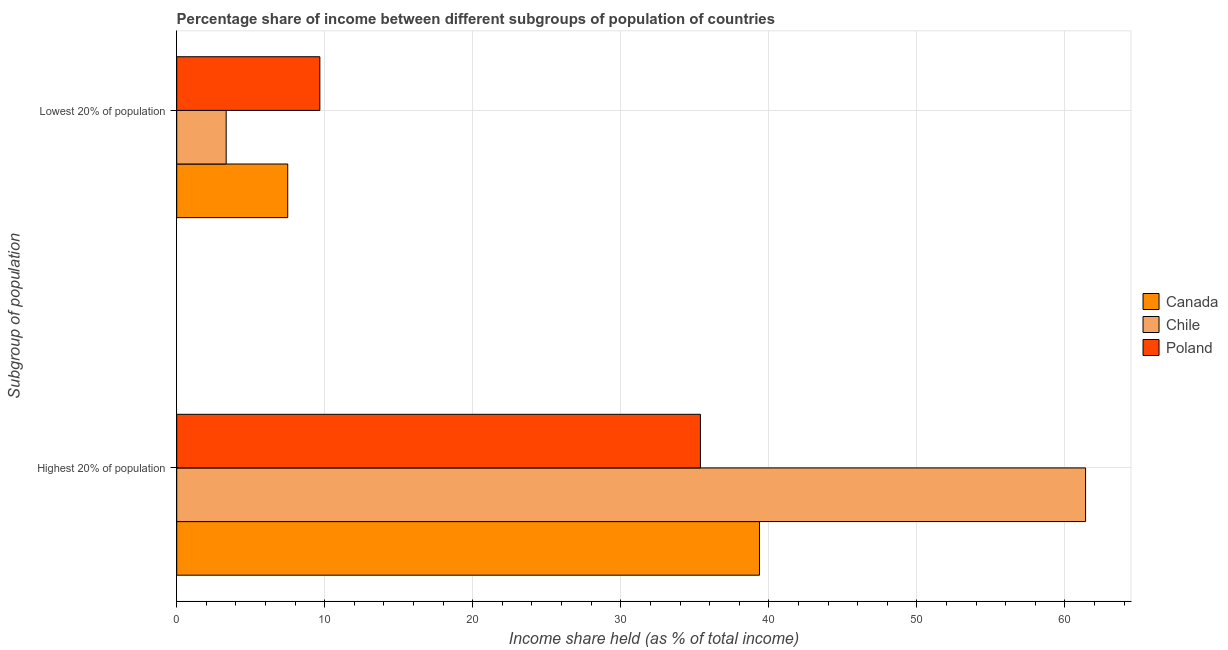How many different coloured bars are there?
Ensure brevity in your answer.  3. How many groups of bars are there?
Provide a short and direct response. 2. Are the number of bars on each tick of the Y-axis equal?
Keep it short and to the point. Yes. How many bars are there on the 1st tick from the top?
Offer a very short reply. 3. How many bars are there on the 2nd tick from the bottom?
Ensure brevity in your answer.  3. What is the label of the 1st group of bars from the top?
Your answer should be very brief. Lowest 20% of population. What is the income share held by lowest 20% of the population in Chile?
Your answer should be very brief. 3.34. Across all countries, what is the maximum income share held by highest 20% of the population?
Keep it short and to the point. 61.4. Across all countries, what is the minimum income share held by highest 20% of the population?
Offer a terse response. 35.38. In which country was the income share held by lowest 20% of the population maximum?
Offer a very short reply. Poland. In which country was the income share held by highest 20% of the population minimum?
Give a very brief answer. Poland. What is the total income share held by lowest 20% of the population in the graph?
Ensure brevity in your answer.  20.51. What is the difference between the income share held by highest 20% of the population in Poland and that in Canada?
Provide a short and direct response. -3.99. What is the difference between the income share held by lowest 20% of the population in Canada and the income share held by highest 20% of the population in Poland?
Provide a succinct answer. -27.88. What is the average income share held by highest 20% of the population per country?
Provide a short and direct response. 45.38. What is the difference between the income share held by lowest 20% of the population and income share held by highest 20% of the population in Poland?
Your response must be concise. -25.71. In how many countries, is the income share held by highest 20% of the population greater than 60 %?
Offer a very short reply. 1. What is the ratio of the income share held by lowest 20% of the population in Poland to that in Canada?
Make the answer very short. 1.29. What does the 2nd bar from the bottom in Highest 20% of population represents?
Your response must be concise. Chile. What is the difference between two consecutive major ticks on the X-axis?
Your answer should be compact. 10. Are the values on the major ticks of X-axis written in scientific E-notation?
Your answer should be compact. No. Does the graph contain any zero values?
Give a very brief answer. No. What is the title of the graph?
Your answer should be very brief. Percentage share of income between different subgroups of population of countries. Does "Guatemala" appear as one of the legend labels in the graph?
Make the answer very short. No. What is the label or title of the X-axis?
Provide a succinct answer. Income share held (as % of total income). What is the label or title of the Y-axis?
Provide a short and direct response. Subgroup of population. What is the Income share held (as % of total income) in Canada in Highest 20% of population?
Your response must be concise. 39.37. What is the Income share held (as % of total income) in Chile in Highest 20% of population?
Your response must be concise. 61.4. What is the Income share held (as % of total income) in Poland in Highest 20% of population?
Your response must be concise. 35.38. What is the Income share held (as % of total income) of Canada in Lowest 20% of population?
Provide a short and direct response. 7.5. What is the Income share held (as % of total income) in Chile in Lowest 20% of population?
Ensure brevity in your answer.  3.34. What is the Income share held (as % of total income) in Poland in Lowest 20% of population?
Give a very brief answer. 9.67. Across all Subgroup of population, what is the maximum Income share held (as % of total income) of Canada?
Your answer should be very brief. 39.37. Across all Subgroup of population, what is the maximum Income share held (as % of total income) in Chile?
Your answer should be very brief. 61.4. Across all Subgroup of population, what is the maximum Income share held (as % of total income) in Poland?
Your answer should be compact. 35.38. Across all Subgroup of population, what is the minimum Income share held (as % of total income) of Canada?
Your answer should be compact. 7.5. Across all Subgroup of population, what is the minimum Income share held (as % of total income) in Chile?
Give a very brief answer. 3.34. Across all Subgroup of population, what is the minimum Income share held (as % of total income) in Poland?
Your answer should be very brief. 9.67. What is the total Income share held (as % of total income) of Canada in the graph?
Your response must be concise. 46.87. What is the total Income share held (as % of total income) in Chile in the graph?
Make the answer very short. 64.74. What is the total Income share held (as % of total income) in Poland in the graph?
Provide a short and direct response. 45.05. What is the difference between the Income share held (as % of total income) in Canada in Highest 20% of population and that in Lowest 20% of population?
Keep it short and to the point. 31.87. What is the difference between the Income share held (as % of total income) of Chile in Highest 20% of population and that in Lowest 20% of population?
Give a very brief answer. 58.06. What is the difference between the Income share held (as % of total income) of Poland in Highest 20% of population and that in Lowest 20% of population?
Your answer should be very brief. 25.71. What is the difference between the Income share held (as % of total income) of Canada in Highest 20% of population and the Income share held (as % of total income) of Chile in Lowest 20% of population?
Your answer should be very brief. 36.03. What is the difference between the Income share held (as % of total income) in Canada in Highest 20% of population and the Income share held (as % of total income) in Poland in Lowest 20% of population?
Make the answer very short. 29.7. What is the difference between the Income share held (as % of total income) in Chile in Highest 20% of population and the Income share held (as % of total income) in Poland in Lowest 20% of population?
Ensure brevity in your answer.  51.73. What is the average Income share held (as % of total income) in Canada per Subgroup of population?
Your response must be concise. 23.43. What is the average Income share held (as % of total income) of Chile per Subgroup of population?
Keep it short and to the point. 32.37. What is the average Income share held (as % of total income) in Poland per Subgroup of population?
Provide a succinct answer. 22.52. What is the difference between the Income share held (as % of total income) in Canada and Income share held (as % of total income) in Chile in Highest 20% of population?
Make the answer very short. -22.03. What is the difference between the Income share held (as % of total income) in Canada and Income share held (as % of total income) in Poland in Highest 20% of population?
Offer a very short reply. 3.99. What is the difference between the Income share held (as % of total income) of Chile and Income share held (as % of total income) of Poland in Highest 20% of population?
Give a very brief answer. 26.02. What is the difference between the Income share held (as % of total income) of Canada and Income share held (as % of total income) of Chile in Lowest 20% of population?
Keep it short and to the point. 4.16. What is the difference between the Income share held (as % of total income) in Canada and Income share held (as % of total income) in Poland in Lowest 20% of population?
Provide a succinct answer. -2.17. What is the difference between the Income share held (as % of total income) of Chile and Income share held (as % of total income) of Poland in Lowest 20% of population?
Your response must be concise. -6.33. What is the ratio of the Income share held (as % of total income) of Canada in Highest 20% of population to that in Lowest 20% of population?
Provide a succinct answer. 5.25. What is the ratio of the Income share held (as % of total income) in Chile in Highest 20% of population to that in Lowest 20% of population?
Your answer should be very brief. 18.38. What is the ratio of the Income share held (as % of total income) of Poland in Highest 20% of population to that in Lowest 20% of population?
Provide a short and direct response. 3.66. What is the difference between the highest and the second highest Income share held (as % of total income) of Canada?
Ensure brevity in your answer.  31.87. What is the difference between the highest and the second highest Income share held (as % of total income) in Chile?
Ensure brevity in your answer.  58.06. What is the difference between the highest and the second highest Income share held (as % of total income) in Poland?
Provide a succinct answer. 25.71. What is the difference between the highest and the lowest Income share held (as % of total income) of Canada?
Offer a very short reply. 31.87. What is the difference between the highest and the lowest Income share held (as % of total income) in Chile?
Give a very brief answer. 58.06. What is the difference between the highest and the lowest Income share held (as % of total income) in Poland?
Offer a very short reply. 25.71. 